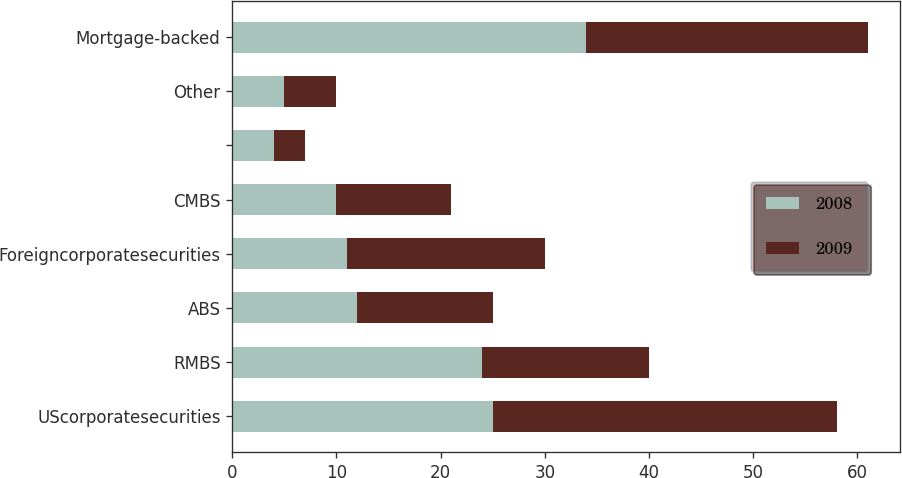<chart> <loc_0><loc_0><loc_500><loc_500><stacked_bar_chart><ecel><fcel>UScorporatesecurities<fcel>RMBS<fcel>ABS<fcel>Foreigncorporatesecurities<fcel>CMBS<fcel>Unnamed: 6<fcel>Other<fcel>Mortgage-backed<nl><fcel>2008<fcel>25<fcel>24<fcel>12<fcel>11<fcel>10<fcel>4<fcel>5<fcel>34<nl><fcel>2009<fcel>33<fcel>16<fcel>13<fcel>19<fcel>11<fcel>3<fcel>5<fcel>27<nl></chart> 